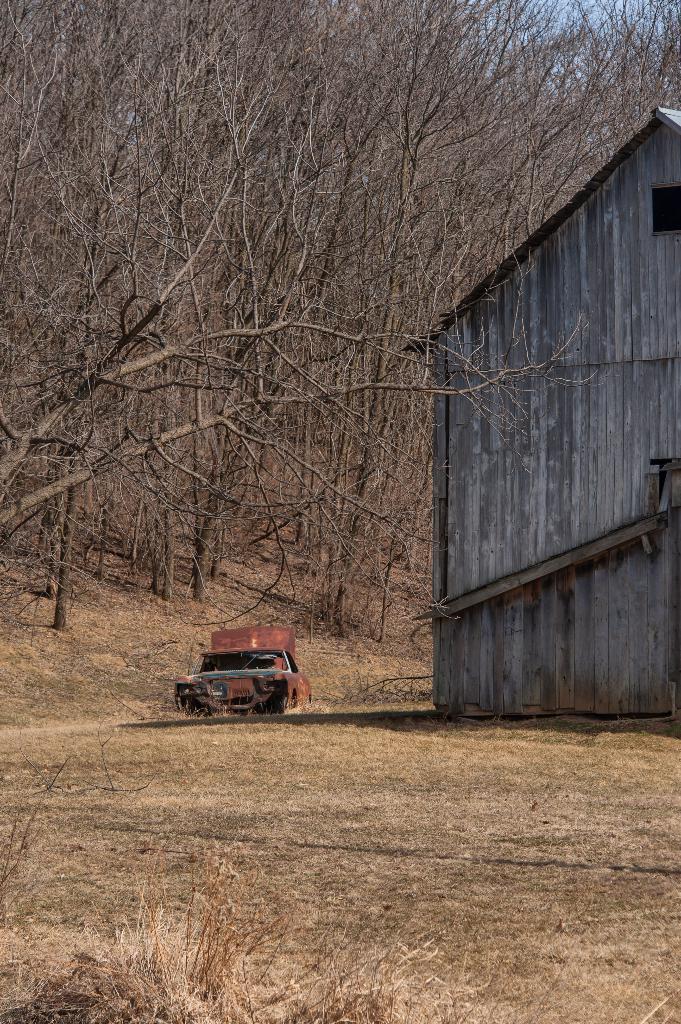In one or two sentences, can you explain what this image depicts? In this image we can see a vehicle is on the road. On the right side of the image there is a house. On the left side of the image there are dry trees. 